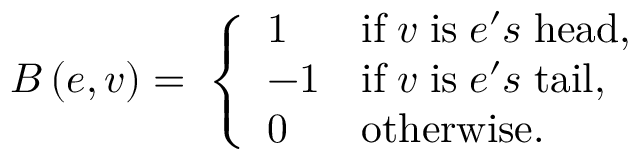Convert formula to latex. <formula><loc_0><loc_0><loc_500><loc_500>B \left ( e , v \right ) = \, \left \{ \begin{array} { l l } { 1 } & { i f \, v \, i s \, e ^ { \prime } s \, h e a d , } \\ { - 1 } & { i f \, v \, i s \, e ^ { \prime } s \, t a i l , } \\ { 0 } & { o t h e r w i s e \dots p } \end{array}</formula> 